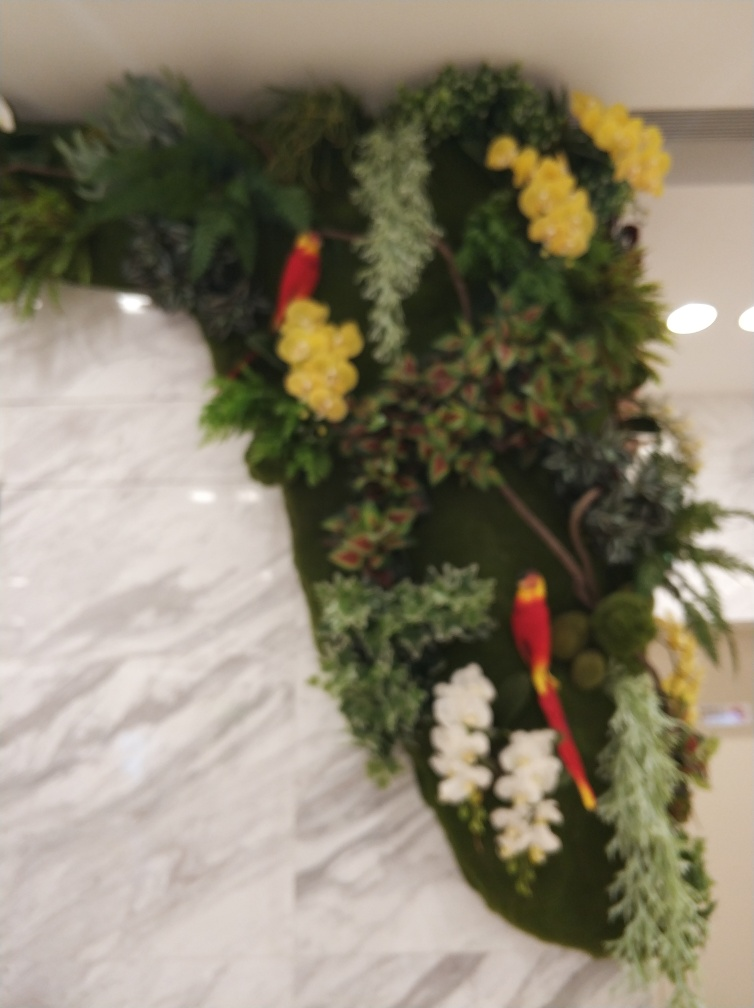Could you describe the textures and elements surrounding the bird? Certainly, the area surrounding the bird is a combination of various plant elements with different textures. There are fluffy, soft-looking plants that could be ferns, as well as some waxy leaves and what appear to be clusters of berries or small fruits. Each contributes to a rich tapestry of plant life that provides a vibrant backdrop to the bird. 